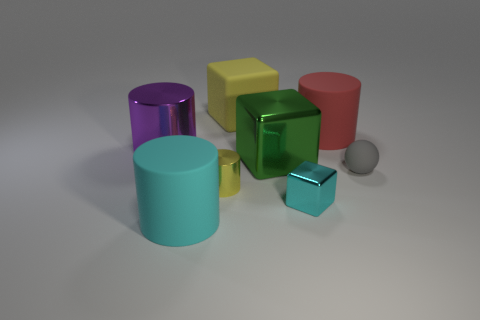Subtract 1 cylinders. How many cylinders are left? 3 Add 2 green metal cubes. How many objects exist? 10 Subtract all blue cylinders. Subtract all green spheres. How many cylinders are left? 4 Subtract all spheres. How many objects are left? 7 Add 1 small yellow metal objects. How many small yellow metal objects exist? 2 Subtract 0 red spheres. How many objects are left? 8 Subtract all large purple metal cylinders. Subtract all big yellow things. How many objects are left? 6 Add 6 yellow cubes. How many yellow cubes are left? 7 